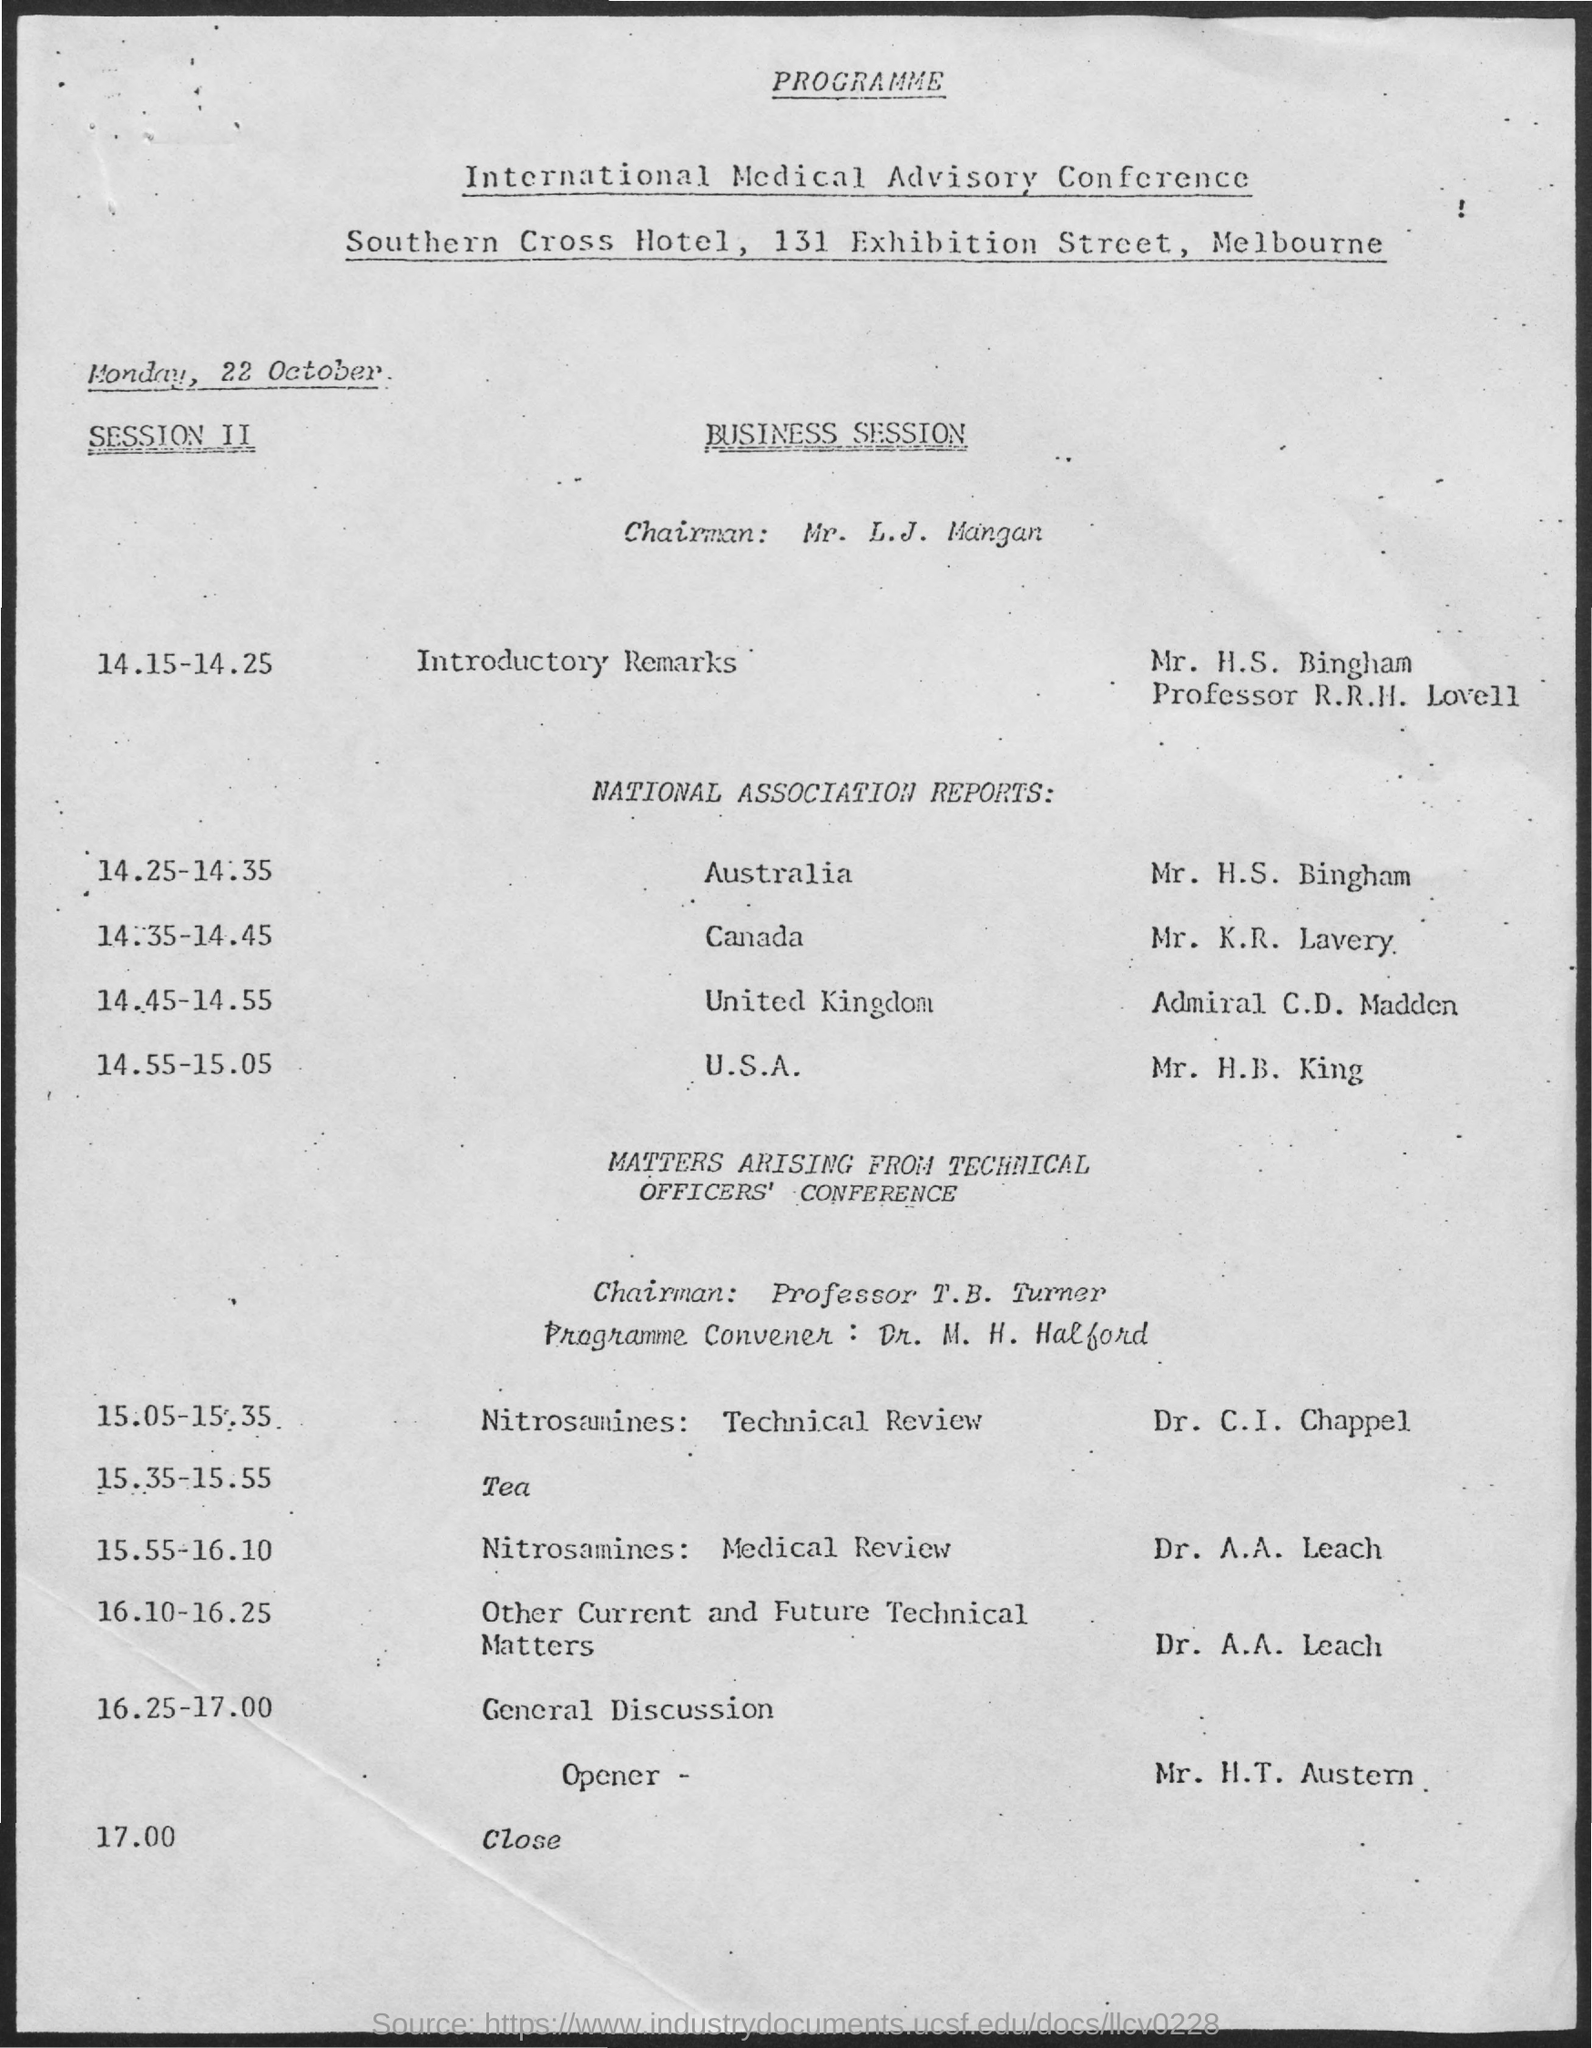Draw attention to some important aspects in this diagram. The International Medical Advisory Conference will be held on Monday, 22 October. The individual who will be presenting the introductory remarks in Session II is Mr. H.S. Bingham. Mr. H.S. Bingham's designation is Professor R.R.H. Lovell. The Chairman for the Business Session is Mr. L.J. Mangan. Dr. A.A. Leach will be presenting on the topic of Nitrosamines during the session. 